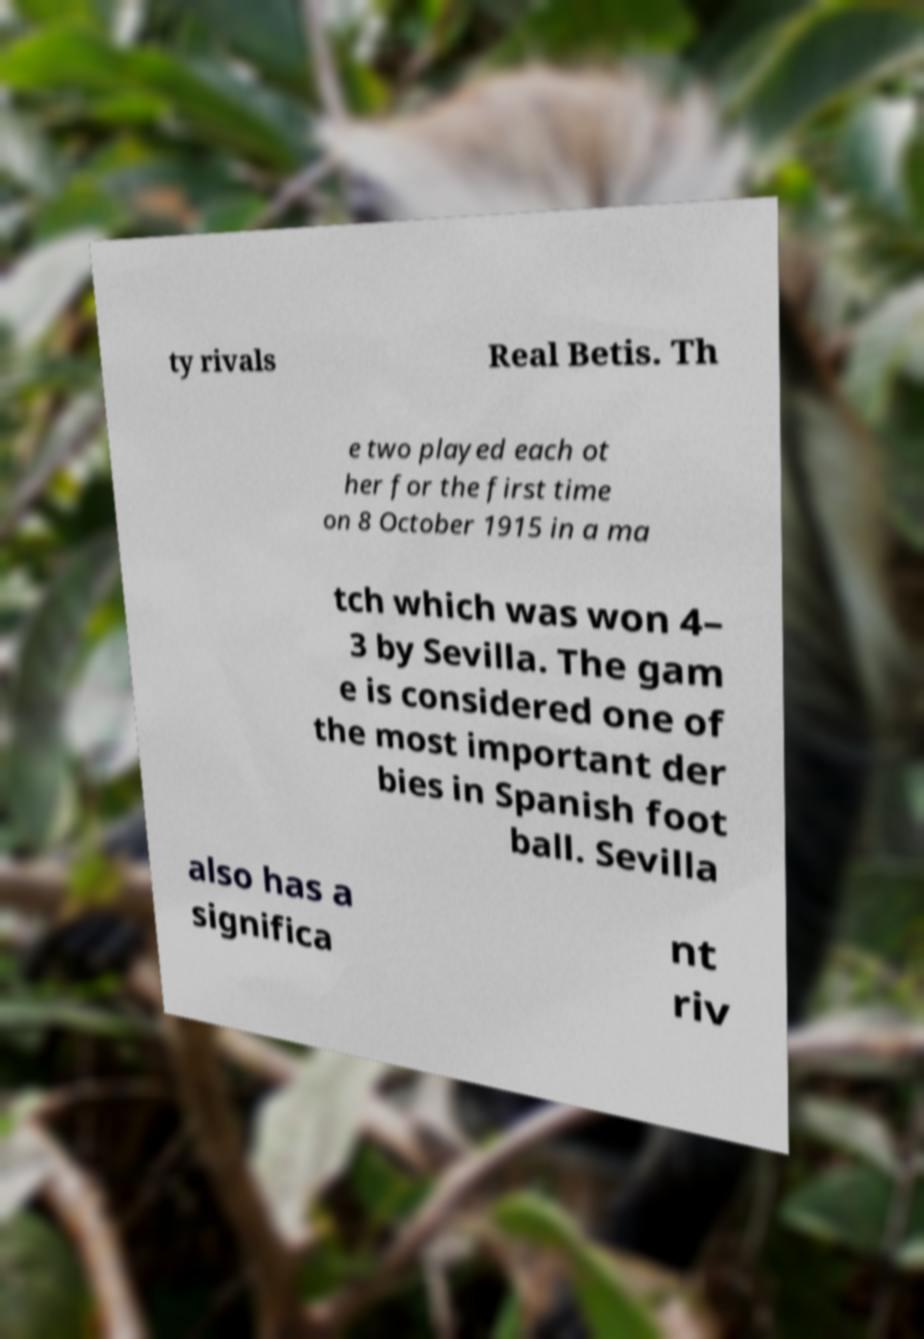I need the written content from this picture converted into text. Can you do that? ty rivals Real Betis. Th e two played each ot her for the first time on 8 October 1915 in a ma tch which was won 4– 3 by Sevilla. The gam e is considered one of the most important der bies in Spanish foot ball. Sevilla also has a significa nt riv 